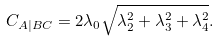Convert formula to latex. <formula><loc_0><loc_0><loc_500><loc_500>C _ { A | B C } = 2 \lambda _ { 0 } \sqrt { \lambda _ { 2 } ^ { 2 } + \lambda _ { 3 } ^ { 2 } + \lambda _ { 4 } ^ { 2 } } .</formula> 